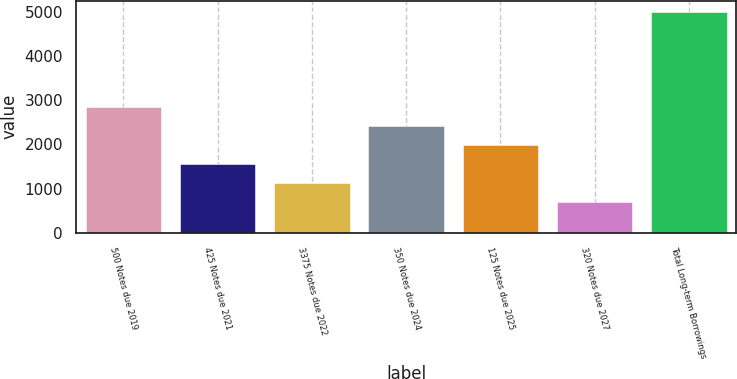Convert chart. <chart><loc_0><loc_0><loc_500><loc_500><bar_chart><fcel>500 Notes due 2019<fcel>425 Notes due 2021<fcel>3375 Notes due 2022<fcel>350 Notes due 2024<fcel>125 Notes due 2025<fcel>320 Notes due 2027<fcel>Total Long-term Borrowings<nl><fcel>2853.5<fcel>1557.2<fcel>1125.1<fcel>2421.4<fcel>1989.3<fcel>693<fcel>5014<nl></chart> 